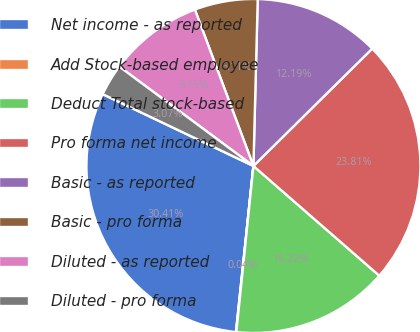<chart> <loc_0><loc_0><loc_500><loc_500><pie_chart><fcel>Net income - as reported<fcel>Add Stock-based employee<fcel>Deduct Total stock-based<fcel>Pro forma net income<fcel>Basic - as reported<fcel>Basic - pro forma<fcel>Diluted - as reported<fcel>Diluted - pro forma<nl><fcel>30.41%<fcel>0.04%<fcel>15.22%<fcel>23.81%<fcel>12.19%<fcel>6.11%<fcel>9.15%<fcel>3.07%<nl></chart> 